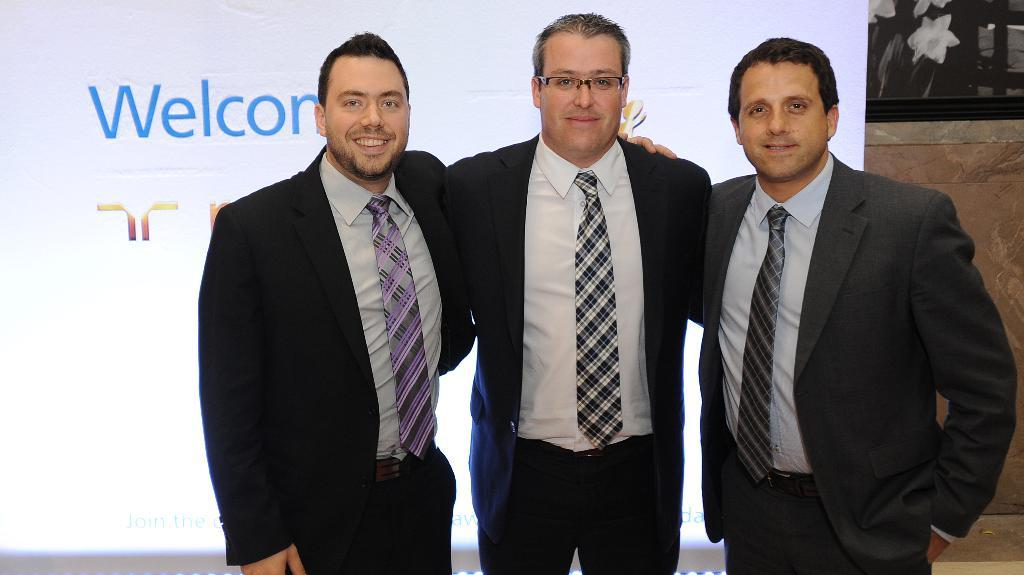How many people are in the image? There are three men standing in the image. What can be seen in the background of the image? There is a display screen with text on it and a wall in the background of the image. How many clocks are hanging on the wall in the image? There are no clocks visible in the image; only a display screen with text and a wall are present in the background. 